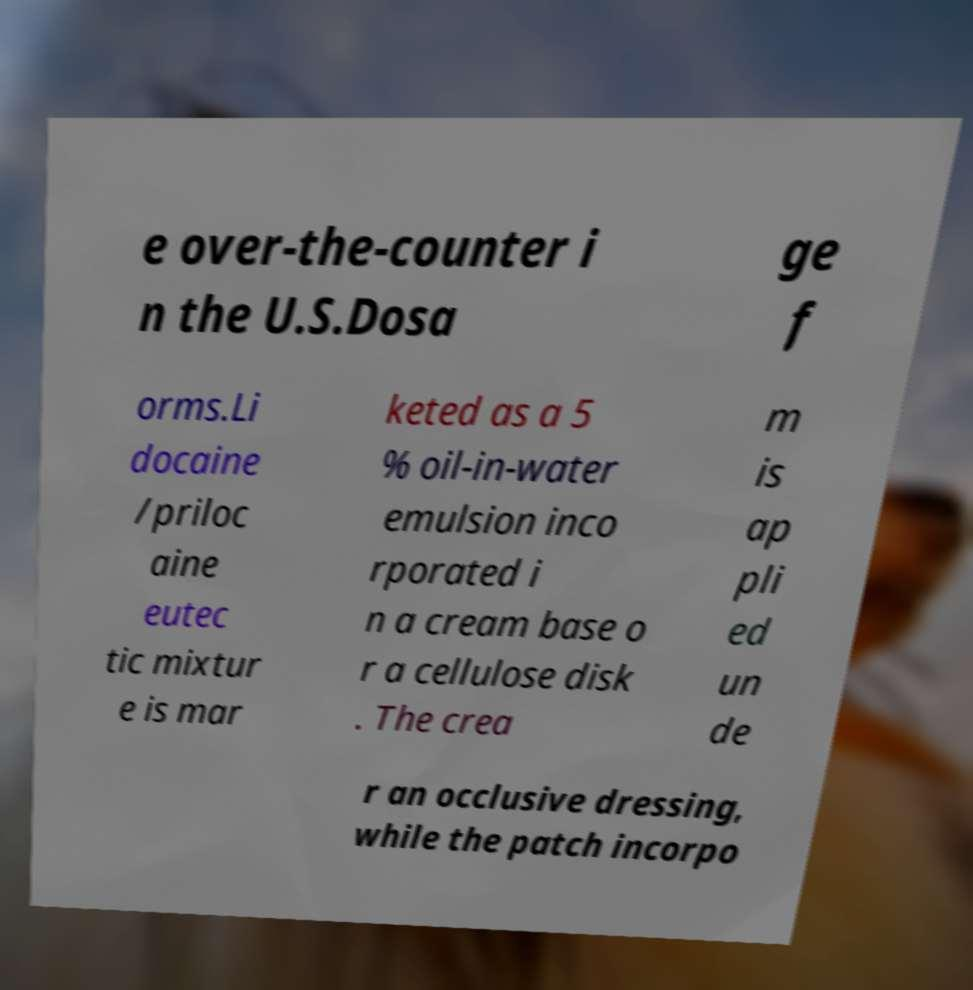Could you extract and type out the text from this image? e over-the-counter i n the U.S.Dosa ge f orms.Li docaine /priloc aine eutec tic mixtur e is mar keted as a 5 % oil-in-water emulsion inco rporated i n a cream base o r a cellulose disk . The crea m is ap pli ed un de r an occlusive dressing, while the patch incorpo 